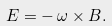Convert formula to latex. <formula><loc_0><loc_0><loc_500><loc_500>E = - \, \omega \times B .</formula> 